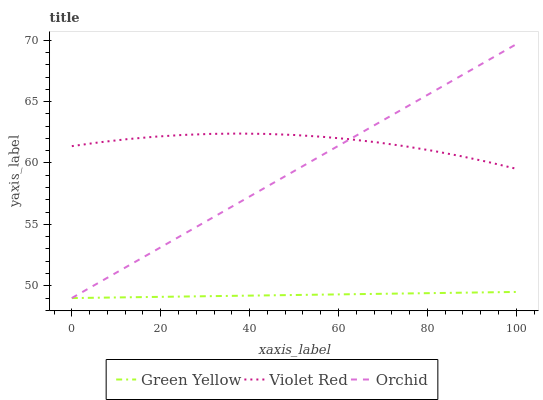Does Green Yellow have the minimum area under the curve?
Answer yes or no. Yes. Does Violet Red have the maximum area under the curve?
Answer yes or no. Yes. Does Orchid have the minimum area under the curve?
Answer yes or no. No. Does Orchid have the maximum area under the curve?
Answer yes or no. No. Is Green Yellow the smoothest?
Answer yes or no. Yes. Is Violet Red the roughest?
Answer yes or no. Yes. Is Orchid the smoothest?
Answer yes or no. No. Is Orchid the roughest?
Answer yes or no. No. Does Green Yellow have the lowest value?
Answer yes or no. Yes. Does Orchid have the highest value?
Answer yes or no. Yes. Does Green Yellow have the highest value?
Answer yes or no. No. Is Green Yellow less than Violet Red?
Answer yes or no. Yes. Is Violet Red greater than Green Yellow?
Answer yes or no. Yes. Does Orchid intersect Green Yellow?
Answer yes or no. Yes. Is Orchid less than Green Yellow?
Answer yes or no. No. Is Orchid greater than Green Yellow?
Answer yes or no. No. Does Green Yellow intersect Violet Red?
Answer yes or no. No. 